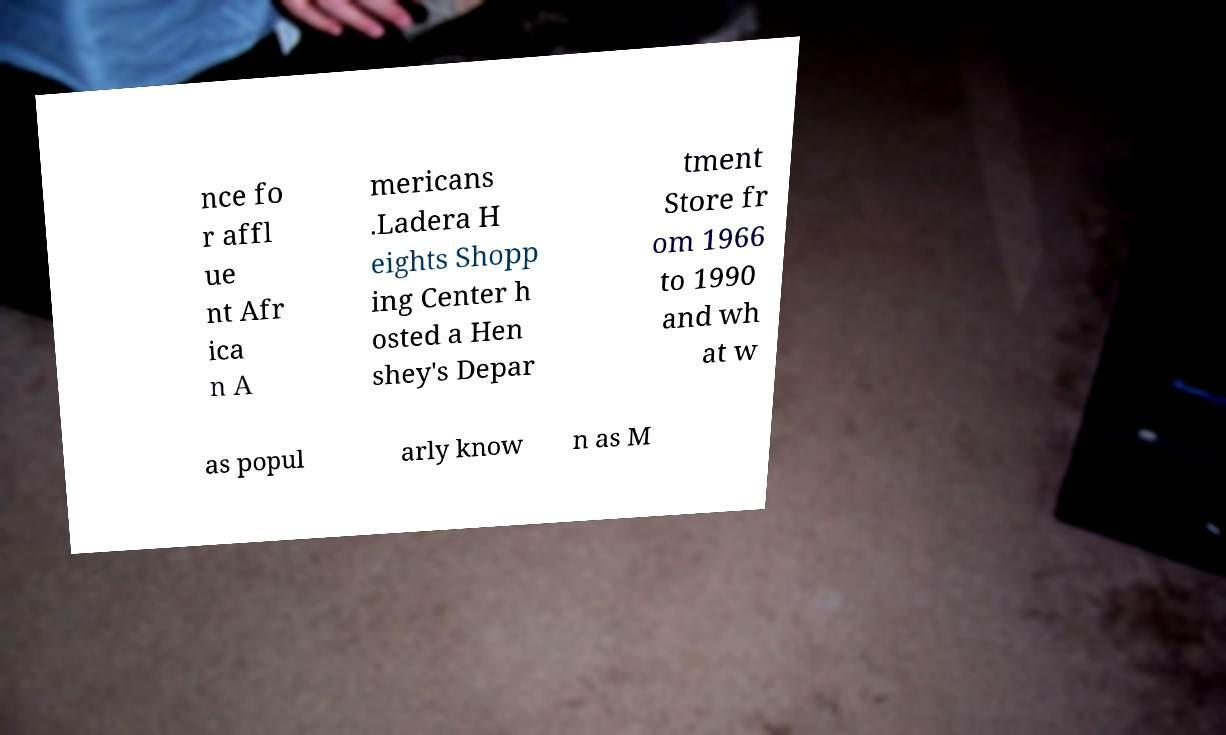There's text embedded in this image that I need extracted. Can you transcribe it verbatim? nce fo r affl ue nt Afr ica n A mericans .Ladera H eights Shopp ing Center h osted a Hen shey's Depar tment Store fr om 1966 to 1990 and wh at w as popul arly know n as M 